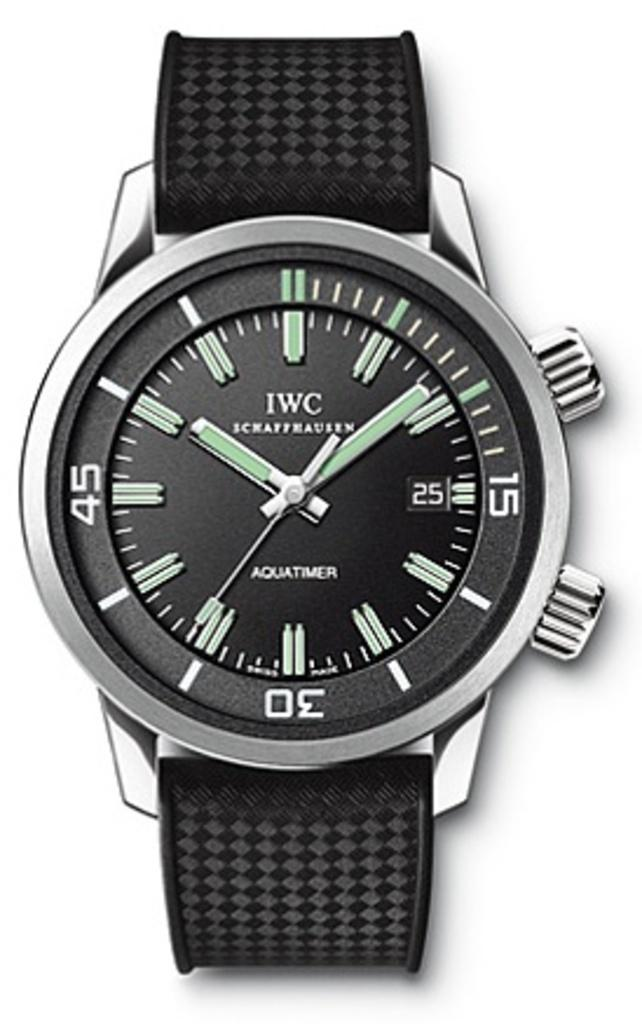Provide a one-sentence caption for the provided image. A black watch displays the time of 10:09. 